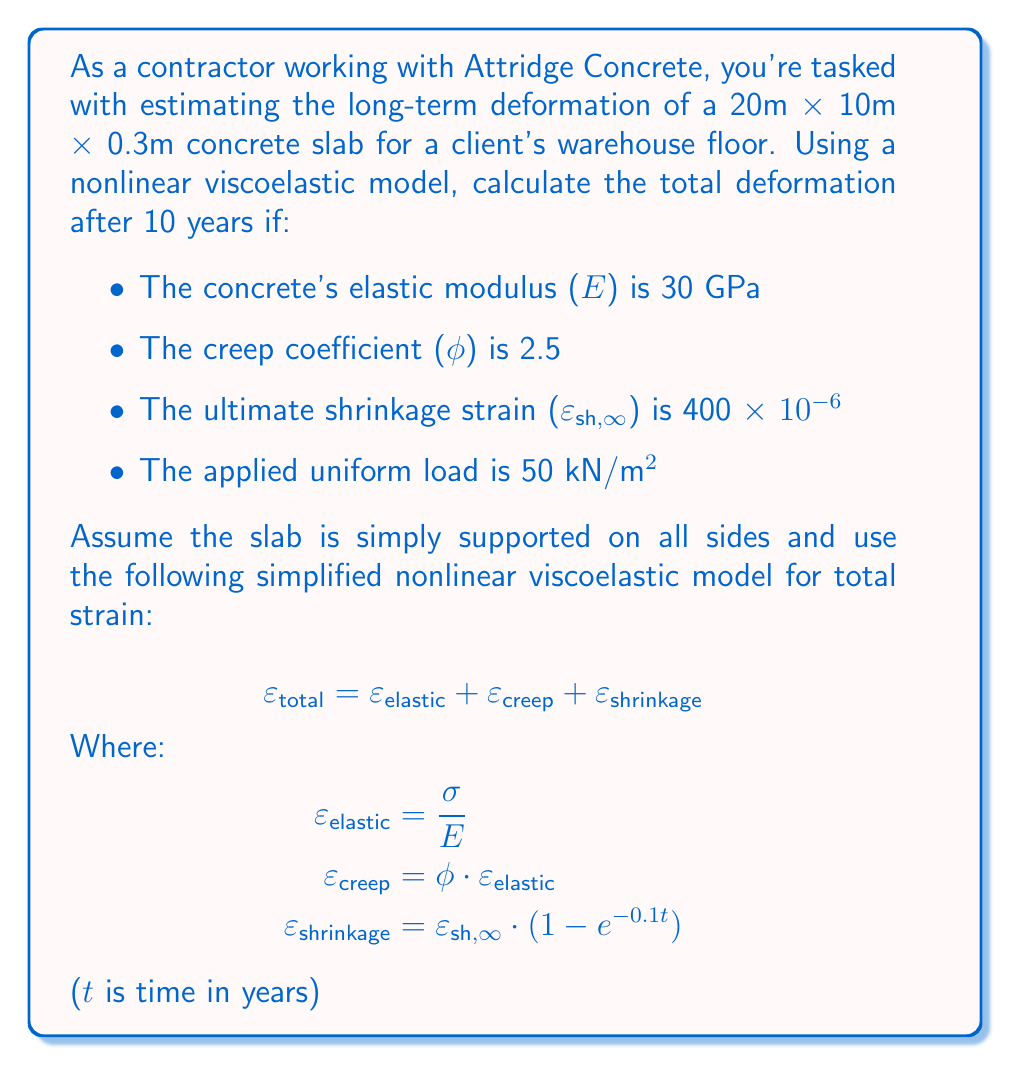Could you help me with this problem? To solve this problem, we'll follow these steps:

1) Calculate the elastic strain:
   First, we need to determine the stress (σ) on the slab.
   $$ σ = \frac{Load}{Area} = \frac{50 \text{ kN/m²} · (20\text{ m} · 10\text{ m})}{20\text{ m} · 10\text{ m} · 0.3\text{ m}} = 166.67 \text{ kPa} $$

   Now we can calculate the elastic strain:
   $$ ε_elastic = \frac{σ}{E} = \frac{166.67 \text{ kPa}}{30 \text{ GPa}} = 5.56 · 10^{-6} $$

2) Calculate the creep strain:
   $$ ε_creep = φ · ε_elastic = 2.5 · 5.56 · 10^{-6} = 13.89 · 10^{-6} $$

3) Calculate the shrinkage strain after 10 years:
   $$ ε_shrinkage = ε_sh,∞ · (1 - e^{-0.1t}) $$
   $$ = 400 · 10^{-6} · (1 - e^{-0.1 · 10}) $$
   $$ = 400 · 10^{-6} · (1 - 0.3679) $$
   $$ = 252.86 · 10^{-6} $$

4) Sum up all strains to get the total strain:
   $$ ε_total = ε_elastic + ε_creep + ε_shrinkage $$
   $$ = (5.56 + 13.89 + 252.86) · 10^{-6} $$
   $$ = 272.31 · 10^{-6} $$

5) Calculate the total deformation:
   Deformation = Strain · Length
   $$ \text{Deformation} = 272.31 · 10^{-6} · 20\text{ m} = 5.45 \text{ mm} $$

Therefore, the estimated total deformation of the slab after 10 years is 5.45 mm.
Answer: 5.45 mm 